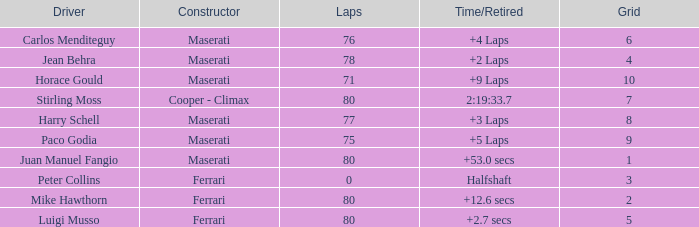Who was driving the Maserati with a Grid smaller than 6, and a Time/Retired of +2 laps? Jean Behra. 